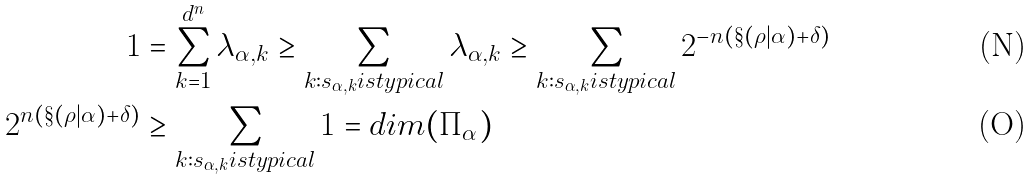Convert formula to latex. <formula><loc_0><loc_0><loc_500><loc_500>1 & = \sum _ { k = 1 } ^ { d ^ { n } } \lambda _ { \alpha , k } \geq \sum _ { k \colon s _ { \alpha , k } i s t y p i c a l } \lambda _ { \alpha , k } \geq \sum _ { k \colon s _ { \alpha , k } i s t y p i c a l } 2 ^ { - n ( \S ( \rho | \alpha ) + \delta ) } \\ 2 ^ { n ( \S ( \rho | \alpha ) + \delta ) } & \geq \sum _ { k \colon s _ { \alpha , k } i s t y p i c a l } 1 = d i m ( \Pi _ { \alpha } )</formula> 